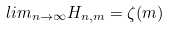Convert formula to latex. <formula><loc_0><loc_0><loc_500><loc_500>l i m _ { n \rightarrow \infty } H _ { n , m } = \zeta ( m )</formula> 